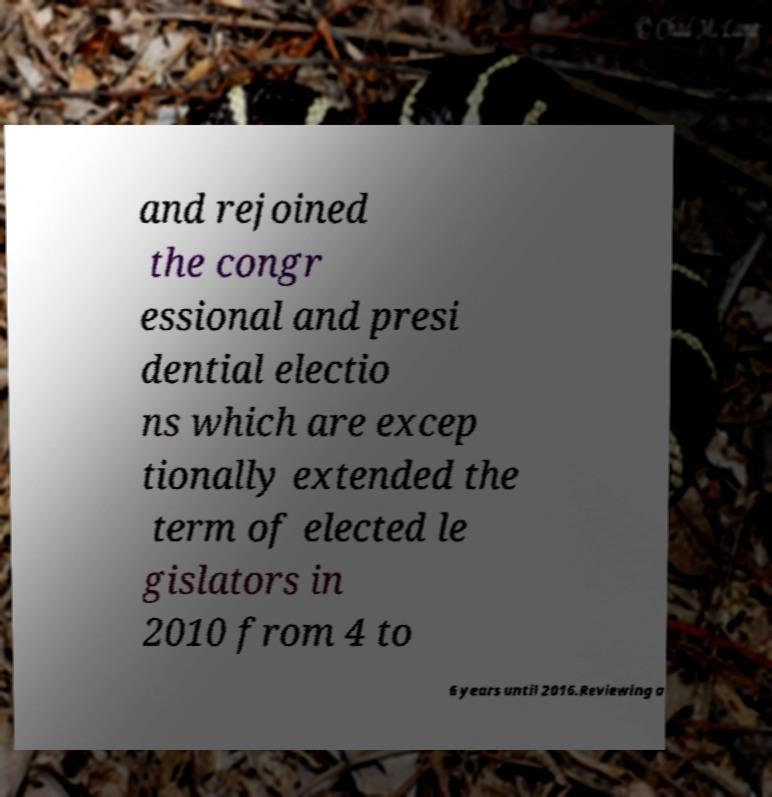There's text embedded in this image that I need extracted. Can you transcribe it verbatim? and rejoined the congr essional and presi dential electio ns which are excep tionally extended the term of elected le gislators in 2010 from 4 to 6 years until 2016.Reviewing a 